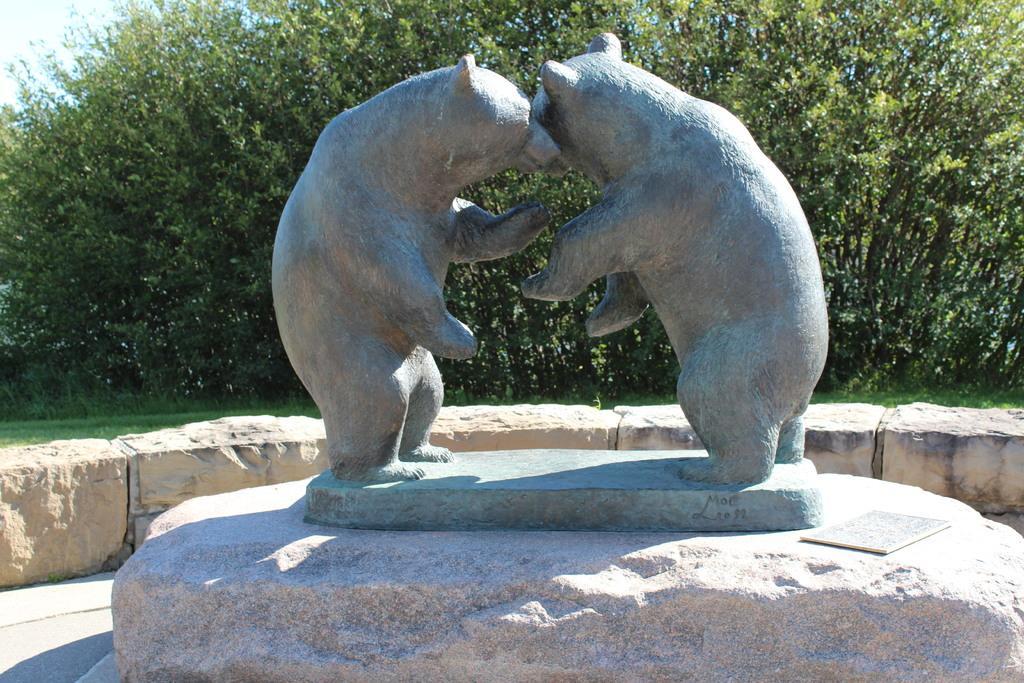Please provide a concise description of this image. In the foreground of this image, there are statues of bear on the stone. Behind it, there is a stone boundary wall. In the background, there are trees, grass and the sky. 